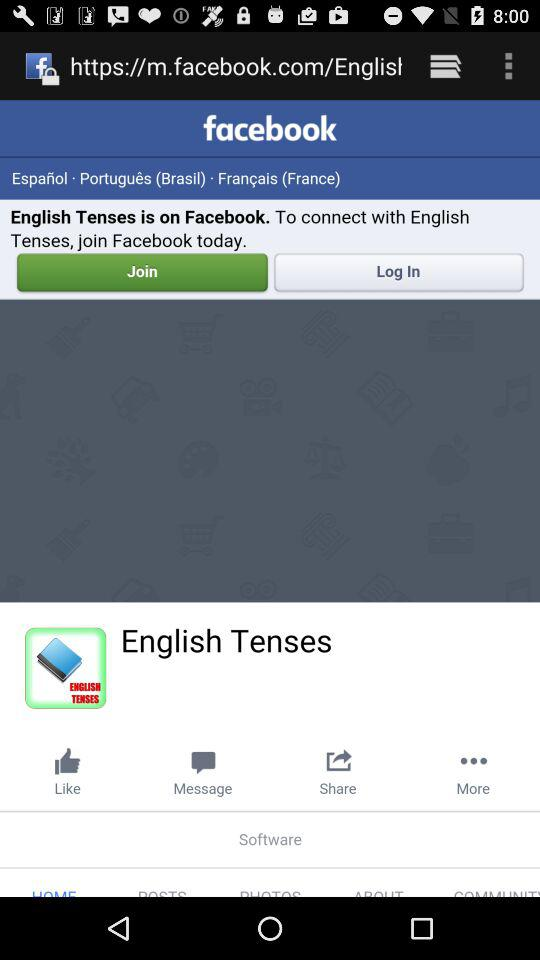What applications can be used to log in to a profile?
When the provided information is insufficient, respond with <no answer>. <no answer> 